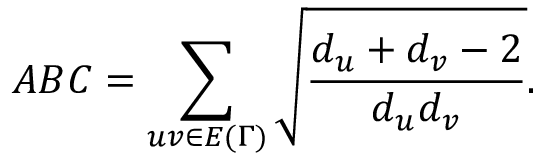Convert formula to latex. <formula><loc_0><loc_0><loc_500><loc_500>A B C = \sum _ { u v \in E { ( \Gamma ) } } \sqrt { \frac { d _ { u } + d _ { v } - 2 } { d _ { u } d _ { v } } } .</formula> 